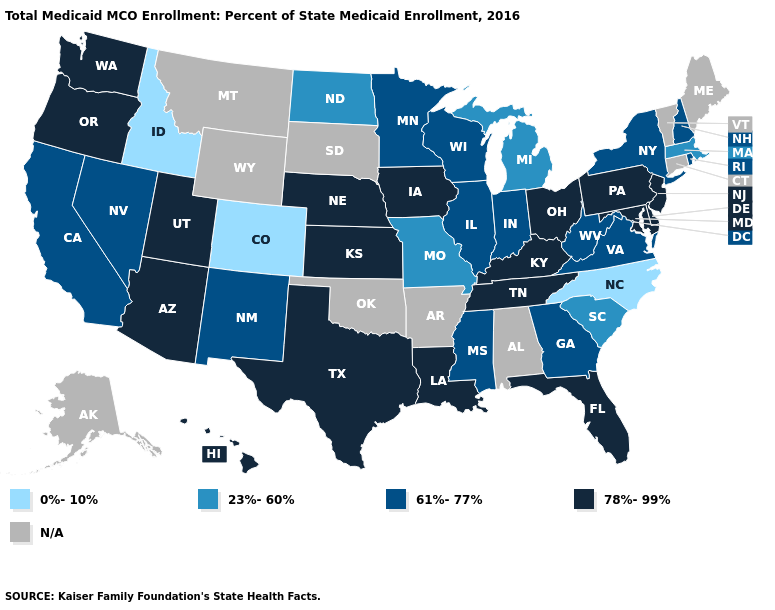What is the value of Nebraska?
Short answer required. 78%-99%. Which states have the lowest value in the Northeast?
Quick response, please. Massachusetts. Which states have the lowest value in the Northeast?
Be succinct. Massachusetts. Among the states that border North Carolina , which have the lowest value?
Write a very short answer. South Carolina. What is the highest value in the Northeast ?
Be succinct. 78%-99%. What is the lowest value in states that border Utah?
Be succinct. 0%-10%. What is the highest value in the USA?
Keep it brief. 78%-99%. What is the value of New Hampshire?
Quick response, please. 61%-77%. Does Kansas have the highest value in the USA?
Quick response, please. Yes. What is the highest value in the South ?
Concise answer only. 78%-99%. What is the highest value in the USA?
Answer briefly. 78%-99%. Name the states that have a value in the range 23%-60%?
Quick response, please. Massachusetts, Michigan, Missouri, North Dakota, South Carolina. What is the value of Utah?
Be succinct. 78%-99%. Does Colorado have the lowest value in the West?
Give a very brief answer. Yes. 